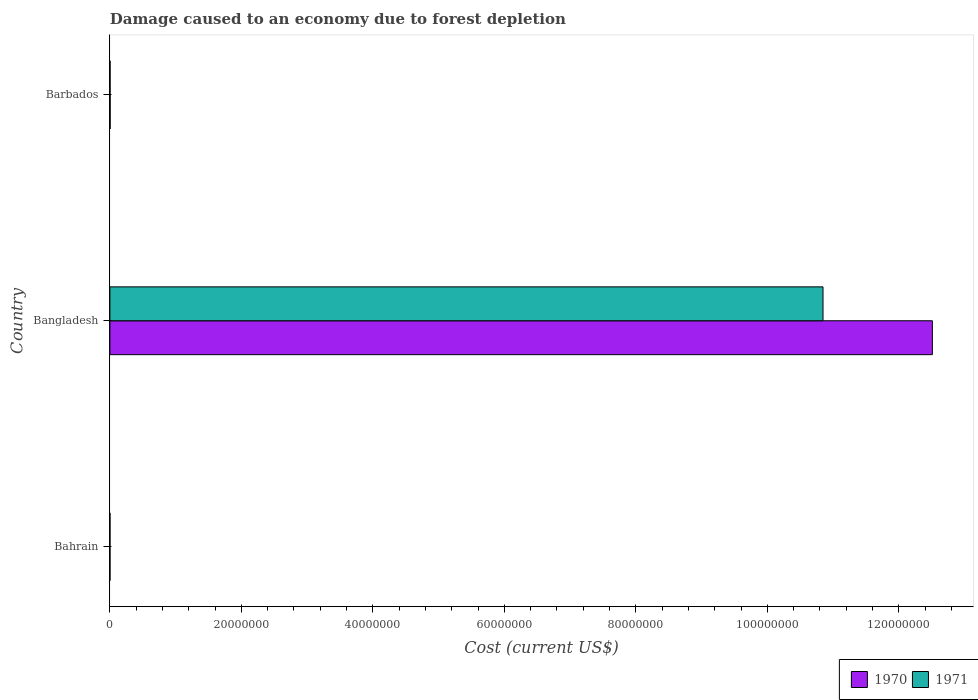How many groups of bars are there?
Offer a very short reply. 3. Are the number of bars per tick equal to the number of legend labels?
Your response must be concise. Yes. What is the cost of damage caused due to forest depletion in 1971 in Bangladesh?
Ensure brevity in your answer.  1.08e+08. Across all countries, what is the maximum cost of damage caused due to forest depletion in 1970?
Give a very brief answer. 1.25e+08. Across all countries, what is the minimum cost of damage caused due to forest depletion in 1970?
Provide a succinct answer. 1.53e+04. In which country was the cost of damage caused due to forest depletion in 1970 minimum?
Provide a succinct answer. Bahrain. What is the total cost of damage caused due to forest depletion in 1971 in the graph?
Offer a terse response. 1.09e+08. What is the difference between the cost of damage caused due to forest depletion in 1971 in Bahrain and that in Barbados?
Provide a succinct answer. -1.70e+04. What is the difference between the cost of damage caused due to forest depletion in 1970 in Bahrain and the cost of damage caused due to forest depletion in 1971 in Barbados?
Ensure brevity in your answer.  -1.34e+04. What is the average cost of damage caused due to forest depletion in 1971 per country?
Your response must be concise. 3.62e+07. What is the difference between the cost of damage caused due to forest depletion in 1970 and cost of damage caused due to forest depletion in 1971 in Bahrain?
Provide a short and direct response. 3638.2. What is the ratio of the cost of damage caused due to forest depletion in 1971 in Bahrain to that in Bangladesh?
Give a very brief answer. 0. Is the cost of damage caused due to forest depletion in 1971 in Bangladesh less than that in Barbados?
Offer a very short reply. No. What is the difference between the highest and the second highest cost of damage caused due to forest depletion in 1971?
Offer a very short reply. 1.08e+08. What is the difference between the highest and the lowest cost of damage caused due to forest depletion in 1971?
Provide a succinct answer. 1.08e+08. In how many countries, is the cost of damage caused due to forest depletion in 1970 greater than the average cost of damage caused due to forest depletion in 1970 taken over all countries?
Make the answer very short. 1. What does the 2nd bar from the bottom in Barbados represents?
Keep it short and to the point. 1971. How many bars are there?
Offer a terse response. 6. How many countries are there in the graph?
Your response must be concise. 3. Does the graph contain grids?
Ensure brevity in your answer.  No. Where does the legend appear in the graph?
Make the answer very short. Bottom right. How are the legend labels stacked?
Offer a very short reply. Horizontal. What is the title of the graph?
Keep it short and to the point. Damage caused to an economy due to forest depletion. Does "1970" appear as one of the legend labels in the graph?
Provide a short and direct response. Yes. What is the label or title of the X-axis?
Your answer should be compact. Cost (current US$). What is the Cost (current US$) in 1970 in Bahrain?
Provide a short and direct response. 1.53e+04. What is the Cost (current US$) of 1971 in Bahrain?
Provide a short and direct response. 1.16e+04. What is the Cost (current US$) of 1970 in Bangladesh?
Make the answer very short. 1.25e+08. What is the Cost (current US$) of 1971 in Bangladesh?
Keep it short and to the point. 1.08e+08. What is the Cost (current US$) of 1970 in Barbados?
Ensure brevity in your answer.  3.70e+04. What is the Cost (current US$) in 1971 in Barbados?
Your answer should be very brief. 2.86e+04. Across all countries, what is the maximum Cost (current US$) in 1970?
Provide a short and direct response. 1.25e+08. Across all countries, what is the maximum Cost (current US$) of 1971?
Give a very brief answer. 1.08e+08. Across all countries, what is the minimum Cost (current US$) of 1970?
Provide a short and direct response. 1.53e+04. Across all countries, what is the minimum Cost (current US$) of 1971?
Keep it short and to the point. 1.16e+04. What is the total Cost (current US$) in 1970 in the graph?
Your answer should be very brief. 1.25e+08. What is the total Cost (current US$) in 1971 in the graph?
Ensure brevity in your answer.  1.09e+08. What is the difference between the Cost (current US$) in 1970 in Bahrain and that in Bangladesh?
Keep it short and to the point. -1.25e+08. What is the difference between the Cost (current US$) of 1971 in Bahrain and that in Bangladesh?
Make the answer very short. -1.08e+08. What is the difference between the Cost (current US$) in 1970 in Bahrain and that in Barbados?
Ensure brevity in your answer.  -2.18e+04. What is the difference between the Cost (current US$) of 1971 in Bahrain and that in Barbados?
Offer a terse response. -1.70e+04. What is the difference between the Cost (current US$) in 1970 in Bangladesh and that in Barbados?
Offer a terse response. 1.25e+08. What is the difference between the Cost (current US$) in 1971 in Bangladesh and that in Barbados?
Your response must be concise. 1.08e+08. What is the difference between the Cost (current US$) in 1970 in Bahrain and the Cost (current US$) in 1971 in Bangladesh?
Make the answer very short. -1.08e+08. What is the difference between the Cost (current US$) of 1970 in Bahrain and the Cost (current US$) of 1971 in Barbados?
Your response must be concise. -1.34e+04. What is the difference between the Cost (current US$) in 1970 in Bangladesh and the Cost (current US$) in 1971 in Barbados?
Make the answer very short. 1.25e+08. What is the average Cost (current US$) in 1970 per country?
Make the answer very short. 4.17e+07. What is the average Cost (current US$) of 1971 per country?
Your answer should be compact. 3.62e+07. What is the difference between the Cost (current US$) of 1970 and Cost (current US$) of 1971 in Bahrain?
Your response must be concise. 3638.2. What is the difference between the Cost (current US$) of 1970 and Cost (current US$) of 1971 in Bangladesh?
Give a very brief answer. 1.66e+07. What is the difference between the Cost (current US$) in 1970 and Cost (current US$) in 1971 in Barbados?
Offer a terse response. 8397.63. What is the ratio of the Cost (current US$) of 1970 in Bahrain to that in Bangladesh?
Make the answer very short. 0. What is the ratio of the Cost (current US$) of 1971 in Bahrain to that in Bangladesh?
Provide a succinct answer. 0. What is the ratio of the Cost (current US$) of 1970 in Bahrain to that in Barbados?
Your response must be concise. 0.41. What is the ratio of the Cost (current US$) in 1971 in Bahrain to that in Barbados?
Provide a short and direct response. 0.41. What is the ratio of the Cost (current US$) in 1970 in Bangladesh to that in Barbados?
Provide a short and direct response. 3378.68. What is the ratio of the Cost (current US$) of 1971 in Bangladesh to that in Barbados?
Offer a very short reply. 3788.69. What is the difference between the highest and the second highest Cost (current US$) of 1970?
Your answer should be compact. 1.25e+08. What is the difference between the highest and the second highest Cost (current US$) in 1971?
Offer a very short reply. 1.08e+08. What is the difference between the highest and the lowest Cost (current US$) of 1970?
Your answer should be compact. 1.25e+08. What is the difference between the highest and the lowest Cost (current US$) of 1971?
Ensure brevity in your answer.  1.08e+08. 